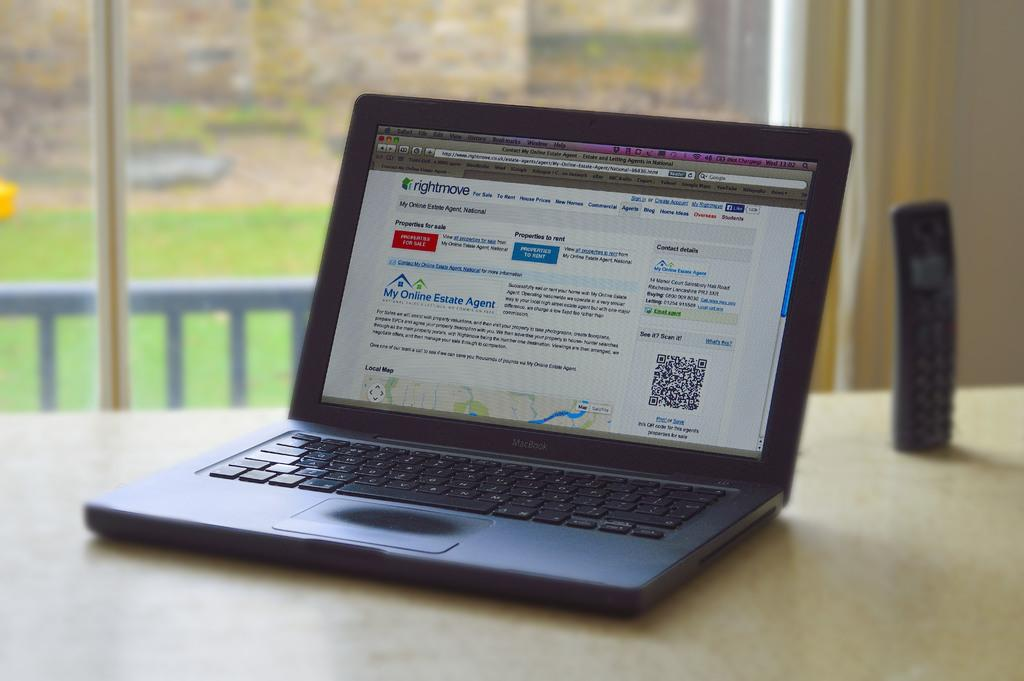<image>
Present a compact description of the photo's key features. An open lap top with my online estate agent written on the screen 